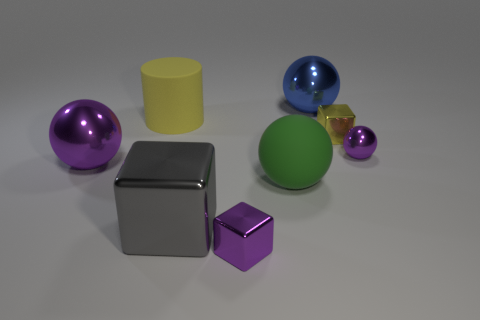Add 1 large objects. How many objects exist? 9 Subtract all large spheres. How many spheres are left? 1 Subtract all cubes. How many objects are left? 5 Subtract 2 cubes. How many cubes are left? 1 Subtract all green balls. How many balls are left? 3 Subtract 0 cyan cylinders. How many objects are left? 8 Subtract all brown blocks. Subtract all cyan spheres. How many blocks are left? 3 Subtract all cyan balls. How many purple cubes are left? 1 Subtract all tiny yellow blocks. Subtract all gray metal things. How many objects are left? 6 Add 8 big purple balls. How many big purple balls are left? 9 